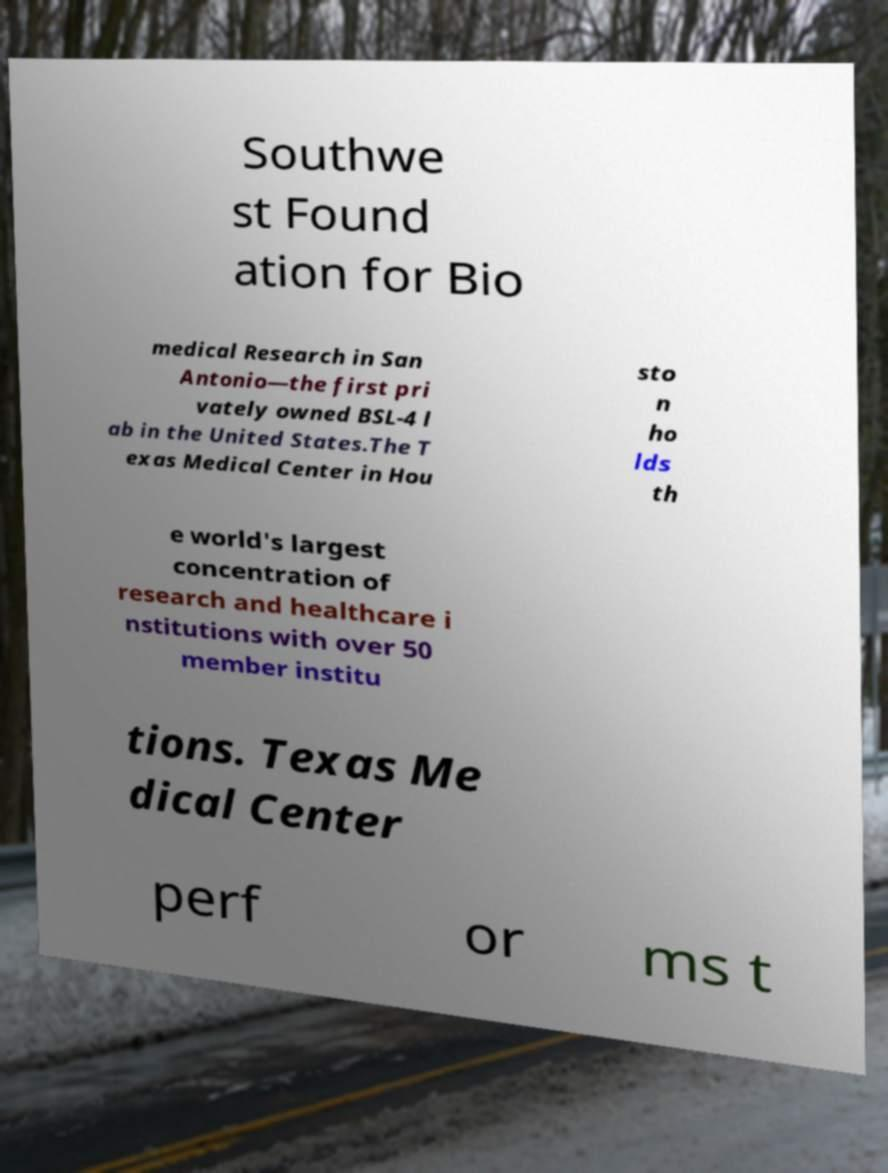Please read and relay the text visible in this image. What does it say? Southwe st Found ation for Bio medical Research in San Antonio—the first pri vately owned BSL-4 l ab in the United States.The T exas Medical Center in Hou sto n ho lds th e world's largest concentration of research and healthcare i nstitutions with over 50 member institu tions. Texas Me dical Center perf or ms t 